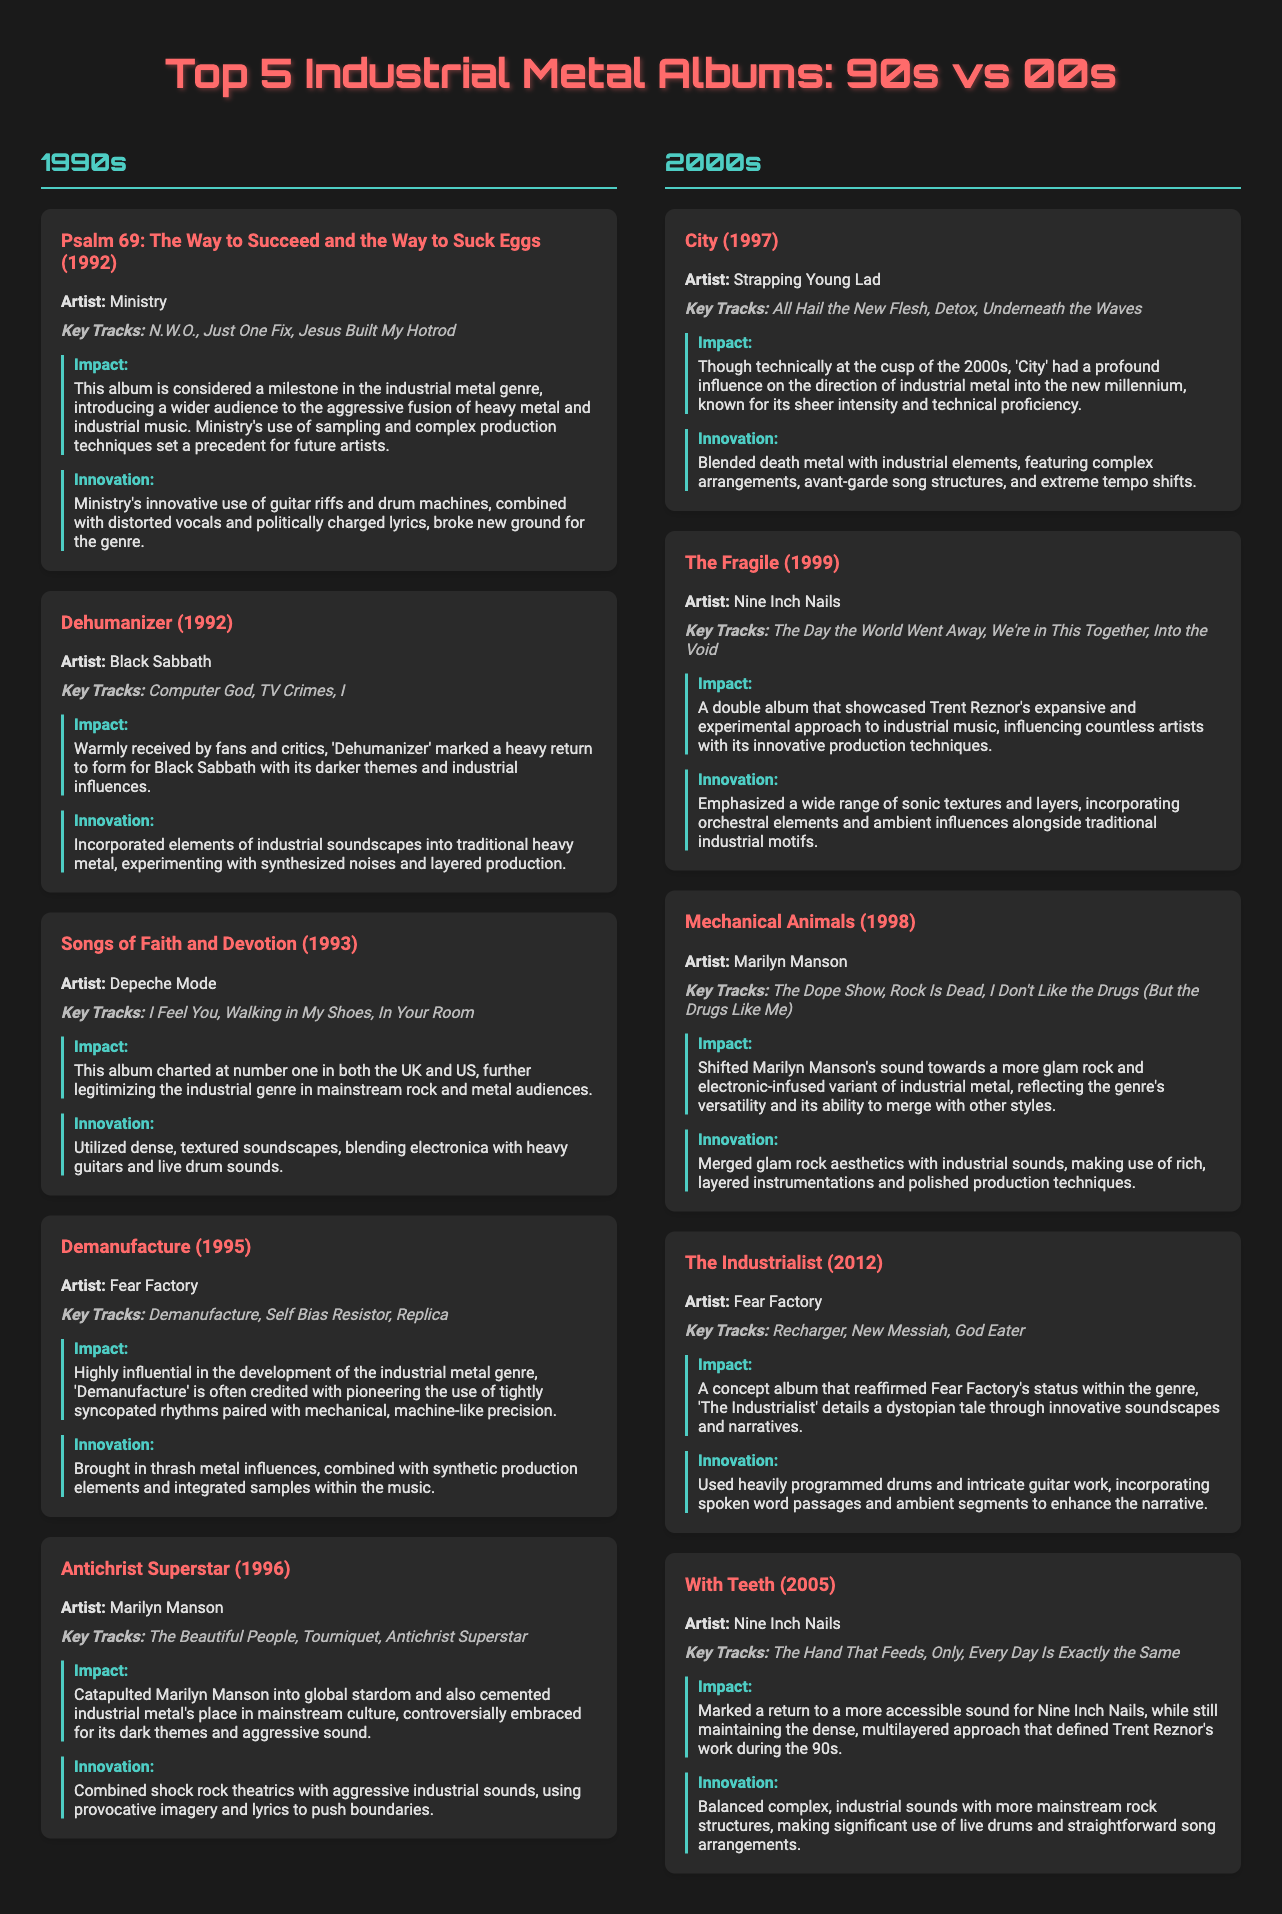What is the top industrial metal album of the 1990s? The top industrial metal album of the 1990s, as presented in the document, is "Psalm 69: The Way to Succeed and the Way to Suck Eggs" by Ministry.
Answer: "Psalm 69: The Way to Succeed and the Way to Suck Eggs" Who is the artist of "Demanufacture"? The artist of "Demanufacture" is Fear Factory, mentioned in the 1990s section of the document.
Answer: Fear Factory How many albums are listed for the 2000s? The document lists five albums for the 2000s, similar to the 1990s section.
Answer: 5 Which album had the key track "The Day the World Went Away"? "The Day the World Went Away" is a key track from "The Fragile" by Nine Inch Nails in the 2000s section.
Answer: "The Fragile" What year was "Antichrist Superstar" released? "Antichrist Superstar" was released in 1996, as indicated in the 1990s section of the document.
Answer: 1996 Which artist's album combined glam rock aesthetics with industrial sounds? The artist is Marilyn Manson, who released "Mechanical Animals" that merged glam rock aesthetics with industrial sounds.
Answer: Marilyn Manson What is a significant impact of the album "Dehumanizer"? "Dehumanizer" is noted for marking a heavy return to form for Black Sabbath with darker themes and industrial influences.
Answer: Heavy return to form What innovative element is associated with "City"? "City" is noted for blending death metal with industrial elements and its complex arrangements.
Answer: Blended death metal What is the significance of "With Teeth" in the document? "With Teeth" is significant for marking a return to a more accessible sound for Nine Inch Nails while maintaining complexity, as stated.
Answer: Return to accessible sound What genre do all the listed albums belong to? All the albums belong to the industrial metal genre, as indicated in the comparison infographic title and description.
Answer: Industrial metal 